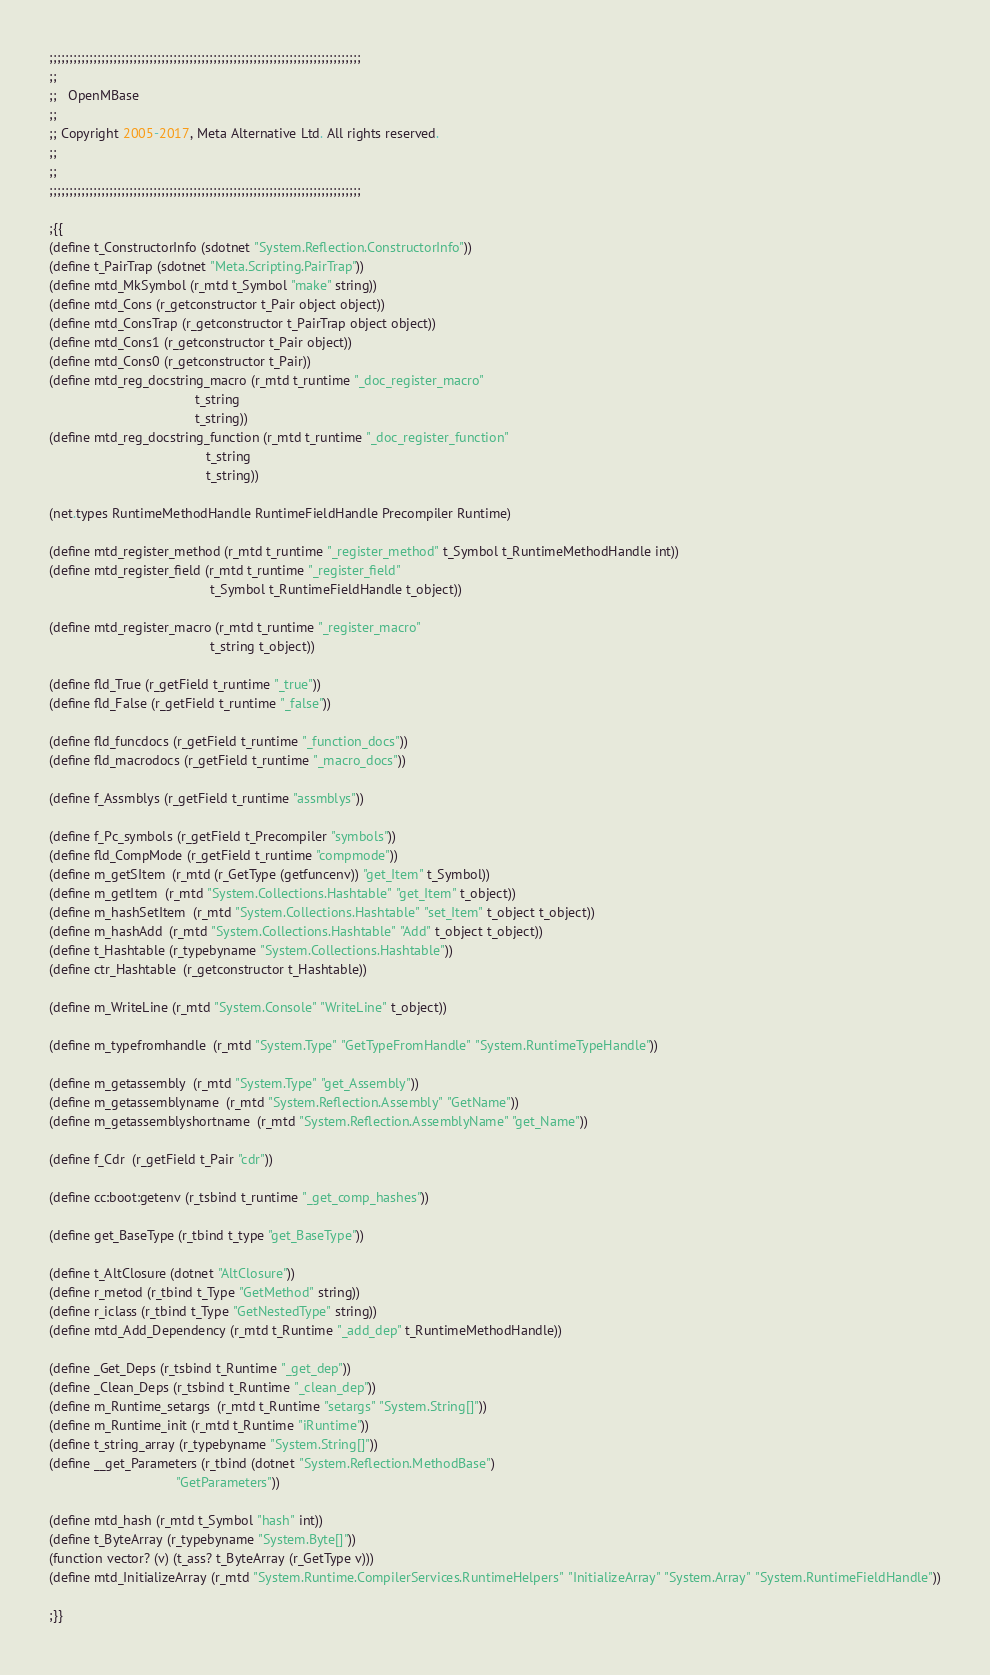<code> <loc_0><loc_0><loc_500><loc_500><_Perl_>;;;;;;;;;;;;;;;;;;;;;;;;;;;;;;;;;;;;;;;;;;;;;;;;;;;;;;;;;;;;;;;;;;;;;;;;;;;;;;
;;
;;   OpenMBase
;;
;; Copyright 2005-2017, Meta Alternative Ltd. All rights reserved.
;;
;;
;;;;;;;;;;;;;;;;;;;;;;;;;;;;;;;;;;;;;;;;;;;;;;;;;;;;;;;;;;;;;;;;;;;;;;;;;;;;;;

;{{
(define t_ConstructorInfo (sdotnet "System.Reflection.ConstructorInfo"))
(define t_PairTrap (sdotnet "Meta.Scripting.PairTrap"))
(define mtd_MkSymbol (r_mtd t_Symbol "make" string))
(define mtd_Cons (r_getconstructor t_Pair object object))
(define mtd_ConsTrap (r_getconstructor t_PairTrap object object))
(define mtd_Cons1 (r_getconstructor t_Pair object))
(define mtd_Cons0 (r_getconstructor t_Pair))
(define mtd_reg_docstring_macro (r_mtd t_runtime "_doc_register_macro"
                                       t_string
                                       t_string))
(define mtd_reg_docstring_function (r_mtd t_runtime "_doc_register_function"
                                          t_string
                                          t_string))

(net.types RuntimeMethodHandle RuntimeFieldHandle Precompiler Runtime)

(define mtd_register_method (r_mtd t_runtime "_register_method" t_Symbol t_RuntimeMethodHandle int))
(define mtd_register_field (r_mtd t_runtime "_register_field"
                                           t_Symbol t_RuntimeFieldHandle t_object))

(define mtd_register_macro (r_mtd t_runtime "_register_macro"
                                           t_string t_object))

(define fld_True (r_getField t_runtime "_true"))
(define fld_False (r_getField t_runtime "_false"))

(define fld_funcdocs (r_getField t_runtime "_function_docs"))
(define fld_macrodocs (r_getField t_runtime "_macro_docs"))

(define f_Assmblys (r_getField t_runtime "assmblys"))

(define f_Pc_symbols (r_getField t_Precompiler "symbols"))
(define fld_CompMode (r_getField t_runtime "compmode"))
(define m_getSItem  (r_mtd (r_GetType (getfuncenv)) "get_Item" t_Symbol))
(define m_getItem  (r_mtd "System.Collections.Hashtable" "get_Item" t_object))
(define m_hashSetItem  (r_mtd "System.Collections.Hashtable" "set_Item" t_object t_object))
(define m_hashAdd  (r_mtd "System.Collections.Hashtable" "Add" t_object t_object))
(define t_Hashtable (r_typebyname "System.Collections.Hashtable"))
(define ctr_Hashtable  (r_getconstructor t_Hashtable))

(define m_WriteLine (r_mtd "System.Console" "WriteLine" t_object))

(define m_typefromhandle  (r_mtd "System.Type" "GetTypeFromHandle" "System.RuntimeTypeHandle"))

(define m_getassembly  (r_mtd "System.Type" "get_Assembly"))
(define m_getassemblyname  (r_mtd "System.Reflection.Assembly" "GetName"))
(define m_getassemblyshortname  (r_mtd "System.Reflection.AssemblyName" "get_Name"))

(define f_Cdr  (r_getField t_Pair "cdr"))

(define cc:boot:getenv (r_tsbind t_runtime "_get_comp_hashes"))

(define get_BaseType (r_tbind t_type "get_BaseType"))

(define t_AltClosure (dotnet "AltClosure"))
(define r_metod (r_tbind t_Type "GetMethod" string))
(define r_iclass (r_tbind t_Type "GetNestedType" string))
(define mtd_Add_Dependency (r_mtd t_Runtime "_add_dep" t_RuntimeMethodHandle))

(define _Get_Deps (r_tsbind t_Runtime "_get_dep"))
(define _Clean_Deps (r_tsbind t_Runtime "_clean_dep"))
(define m_Runtime_setargs  (r_mtd t_Runtime "setargs" "System.String[]"))
(define m_Runtime_init (r_mtd t_Runtime "iRuntime"))
(define t_string_array (r_typebyname "System.String[]"))
(define __get_Parameters (r_tbind (dotnet "System.Reflection.MethodBase")
                                  "GetParameters"))

(define mtd_hash (r_mtd t_Symbol "hash" int))
(define t_ByteArray (r_typebyname "System.Byte[]"))
(function vector? (v) (t_ass? t_ByteArray (r_GetType v)))
(define mtd_InitializeArray (r_mtd "System.Runtime.CompilerServices.RuntimeHelpers" "InitializeArray" "System.Array" "System.RuntimeFieldHandle"))

;}}
</code> 